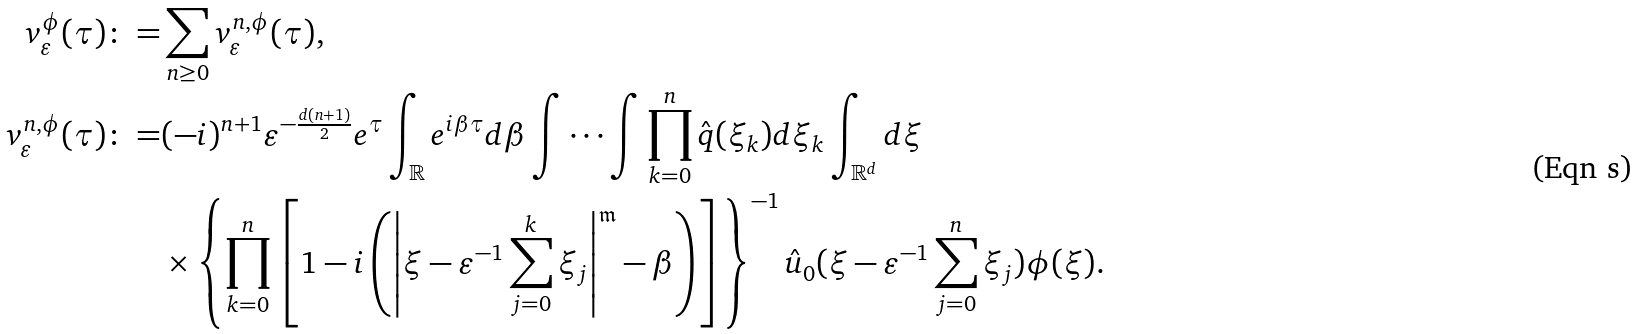<formula> <loc_0><loc_0><loc_500><loc_500>v _ { \varepsilon } ^ { \phi } ( \tau ) \colon = & \sum _ { n \geq 0 } v _ { \varepsilon } ^ { n , \phi } ( \tau ) , \\ v _ { \varepsilon } ^ { n , \phi } ( \tau ) \colon = & ( - i ) ^ { n + 1 } \varepsilon ^ { - \frac { d ( n + 1 ) } { 2 } } e ^ { \tau } \int _ { \mathbb { R } } e ^ { i \beta \tau } d \beta \int \cdots \int \prod _ { k = 0 } ^ { n } \hat { q } ( \xi _ { k } ) d \xi _ { k } \int _ { \mathbb { R } ^ { d } } d \xi \\ & \times \left \{ \prod _ { k = 0 } ^ { n } \left [ 1 - i \left ( \left | \xi - \varepsilon ^ { - 1 } \sum _ { j = 0 } ^ { k } \xi _ { j } \right | ^ { \mathfrak { m } } - \beta \right ) \right ] \right \} ^ { - 1 } \hat { u } _ { 0 } ( \xi - \varepsilon ^ { - 1 } \sum _ { j = 0 } ^ { n } \xi _ { j } ) \phi ( \xi ) .</formula> 